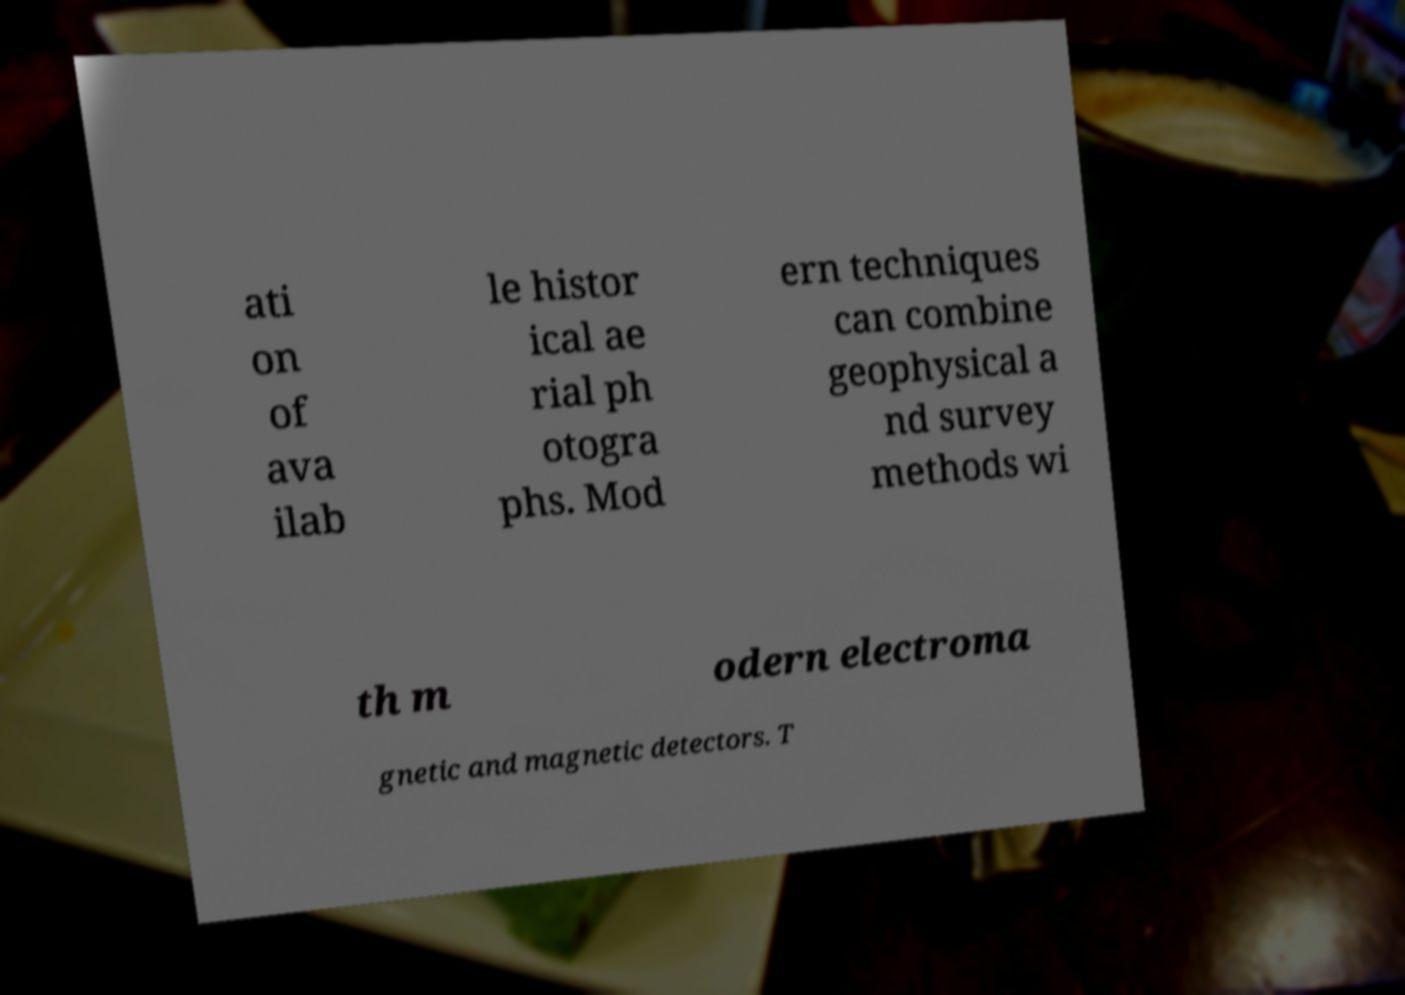Could you assist in decoding the text presented in this image and type it out clearly? ati on of ava ilab le histor ical ae rial ph otogra phs. Mod ern techniques can combine geophysical a nd survey methods wi th m odern electroma gnetic and magnetic detectors. T 